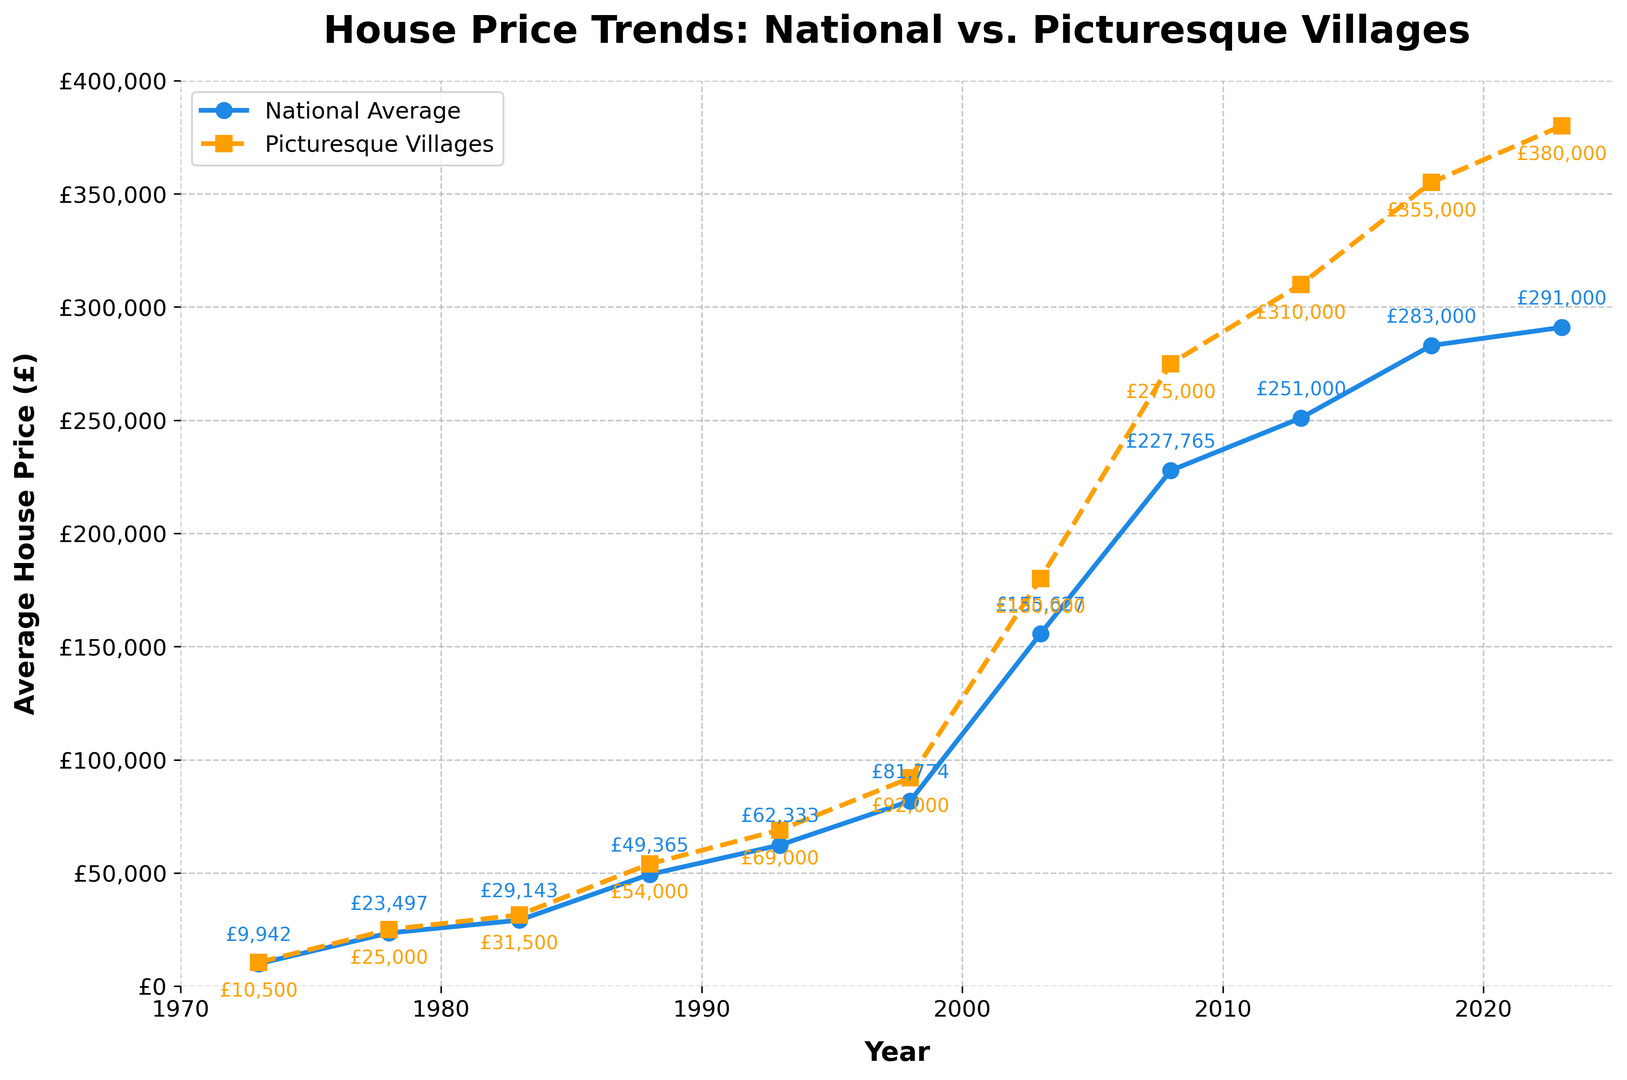What's the difference in house prices between picturesque villages and the national average in 2023? To find the difference in house prices, subtract the national average from the picturesque village average for 2023. The prices are £380,000 for picturesque villages and £291,000 for the national average. So, £380,000 - £291,000 = £89,000
Answer: £89,000 Over which period did picturesque villages see the most significant increase in house prices? Look for the period with the sharpest rise. From 2003 to 2008, the price increased from £180,000 to £275,000, an increase of £95,000. This is the largest increase among all the periods.
Answer: 2003-2008 Which year had the smallest difference between the national average and picturesque villages? Check the differences for each year. In 1973, the difference is £105,000 - £9,942 = £558. This is the smallest difference.
Answer: 1973 Did the national average or picturesque villages have a higher growth rate from 1988 to 1993? Calculate the percentages. For the national average: (£62,333 - £49,365) / £49,365 * 100% = 26.3%. For picturesque villages: (£69,000 - £54,000) / £54,000 * 100% = 27.8%. Picturesque villages had a higher growth rate.
Answer: Picturesque villages Which trend line, national average or picturesque villages, is visually steeper from 2008 to 2013? Observing the slopes between 2008 and 2013, picturesque villages increased from £275,000 to £310,000, while national average increased from £227,765 to £251,000. The steeper increase is visually seen in picturesque villages.
Answer: Picturesque villages How often did the picturesque village house prices surpass the national average by more than £50,000? Check each year: 1993 (£69,000 - £62,333 = £6,667), 1998 (£92,000 - £81,774 = £10,226), 2003 (£180,000 - £155,627 = £24,373), 2008 (£275,000 - £227,765 = £47,235), 2013 (£310,000 - £251,000 = £59,000), 2018 (£355,000 - £283,000 = £72,000), 2023 (£380,000 - £291,000 = £89,000). This happens in 2013, 2018, and 2023.
Answer: 3 times By how much did the national average house prices increase from 1973 to 2023? Calculate the difference: £291,000 in 2023 - £9,942 in 1973. So, £291,000 - £9,942 = £281,058.
Answer: £281,058 On how many occasions did the house prices in picturesque villages reach or exceed 3 times the national average in the same year? Calculate for each year if village prices are 3 times the national average. This does not occur as the highest ratio observed is closer to 1.3 (in 2023).
Answer: 0 occasions Which year had the closest value between the national average and picturesque villages around 2003? Check 5 years before and after 2003: 1998 (£81,774 vs £92,000), 2003 (£155,627 vs £180,000). 1998 has the closest gap of £10,226 compared to £24,373 in 2003.
Answer: 1998 